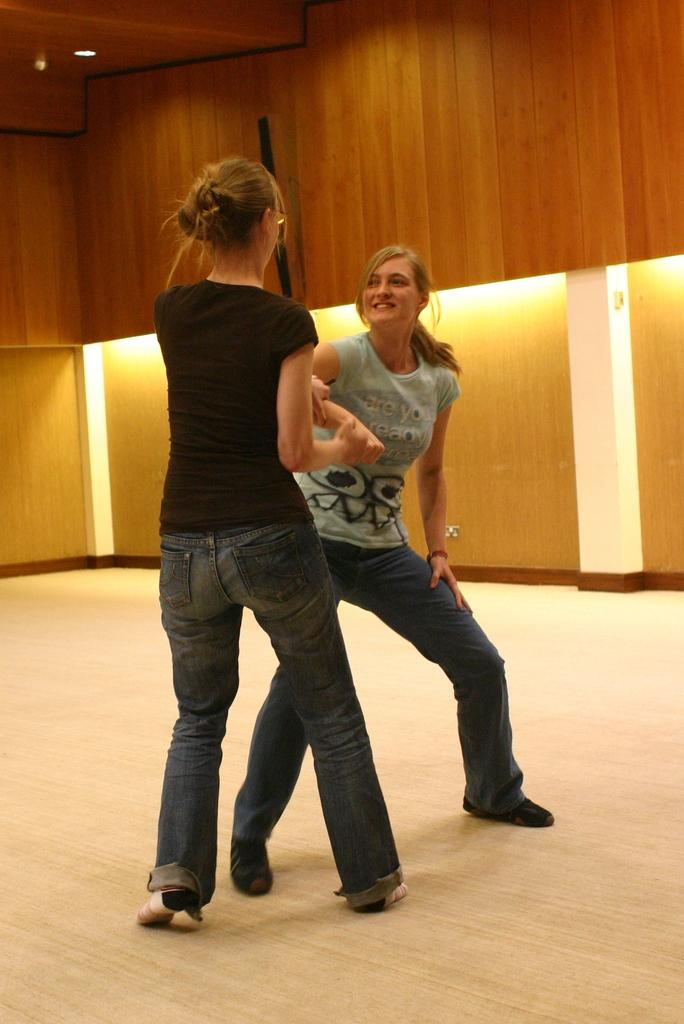How many people are in the image? There are two women in the image. What are the women doing in the image? The women are standing on the floor. What type of surface is the women standing on? The women are standing on the floor. What can be seen in the background of the image? There is a wooden interior visible in the background. What type of dirt can be seen on the floor in the image? There is no dirt visible on the floor in the image. What type of curve is present in the image? There is no curve present in the image. 